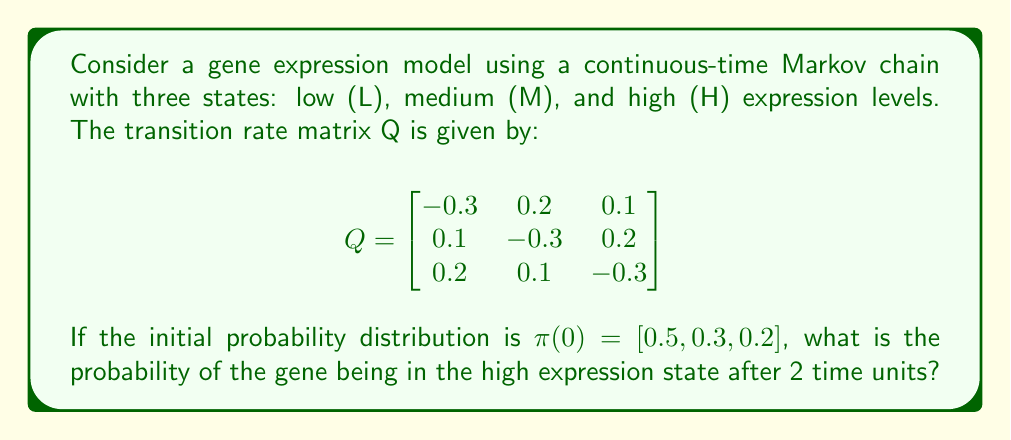Help me with this question. To solve this problem, we need to use the forward Kolmogorov equation:

$$\frac{d\pi(t)}{dt} = \pi(t)Q$$

The solution to this equation is given by:

$$\pi(t) = \pi(0)e^{Qt}$$

where $e^{Qt}$ is the matrix exponential.

Steps to solve:

1) First, we need to calculate $e^{Qt}$ for $t=2$. We can use the eigendecomposition method:

   $Q = PDP^{-1}$, where D is a diagonal matrix of eigenvalues and P is a matrix of eigenvectors.

2) Calculate eigenvalues:
   $\det(Q - \lambda I) = 0$
   $\lambda_1 = 0, \lambda_2 = -0.3, \lambda_3 = -0.6$

3) Find eigenvectors and construct P:
   $$P \approx \begin{bmatrix}
   1 & -1 & 1 \\
   1 & 0 & -2 \\
   1 & 1 & 1
   \end{bmatrix}$$

4) Construct $D$:
   $$D = \begin{bmatrix}
   0 & 0 & 0 \\
   0 & -0.3 & 0 \\
   0 & 0 & -0.6
   \end{bmatrix}$$

5) Calculate $e^{Qt} = Pe^{Dt}P^{-1}$:
   $$e^{Qt} \approx \begin{bmatrix}
   0.3616 & 0.3340 & 0.3044 \\
   0.3253 & 0.3558 & 0.3189 \\
   0.3131 & 0.3102 & 0.3767
   \end{bmatrix}$$

6) Now, we can calculate $\pi(2)$:
   $$\pi(2) = [0.5, 0.3, 0.2] \begin{bmatrix}
   0.3616 & 0.3340 & 0.3044 \\
   0.3253 & 0.3558 & 0.3189 \\
   0.3131 & 0.3102 & 0.3767
   \end{bmatrix}$$

7) Multiplying these matrices:
   $$\pi(2) \approx [0.3412, 0.3364, 0.3224]$$

8) The probability of being in the high expression state (H) after 2 time units is the third component of $\pi(2)$, which is approximately 0.3224.
Answer: 0.3224 